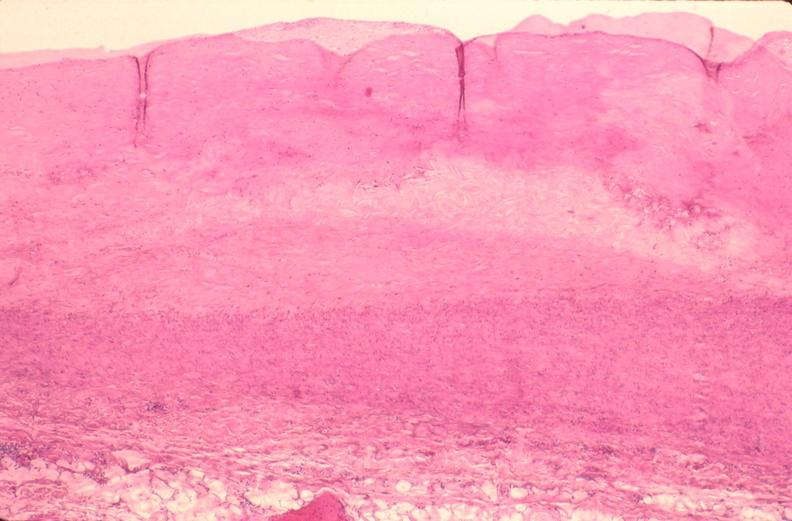does this image show pulmonary artery atherosclerosis in patient with pulmonary hypertension?
Answer the question using a single word or phrase. Yes 